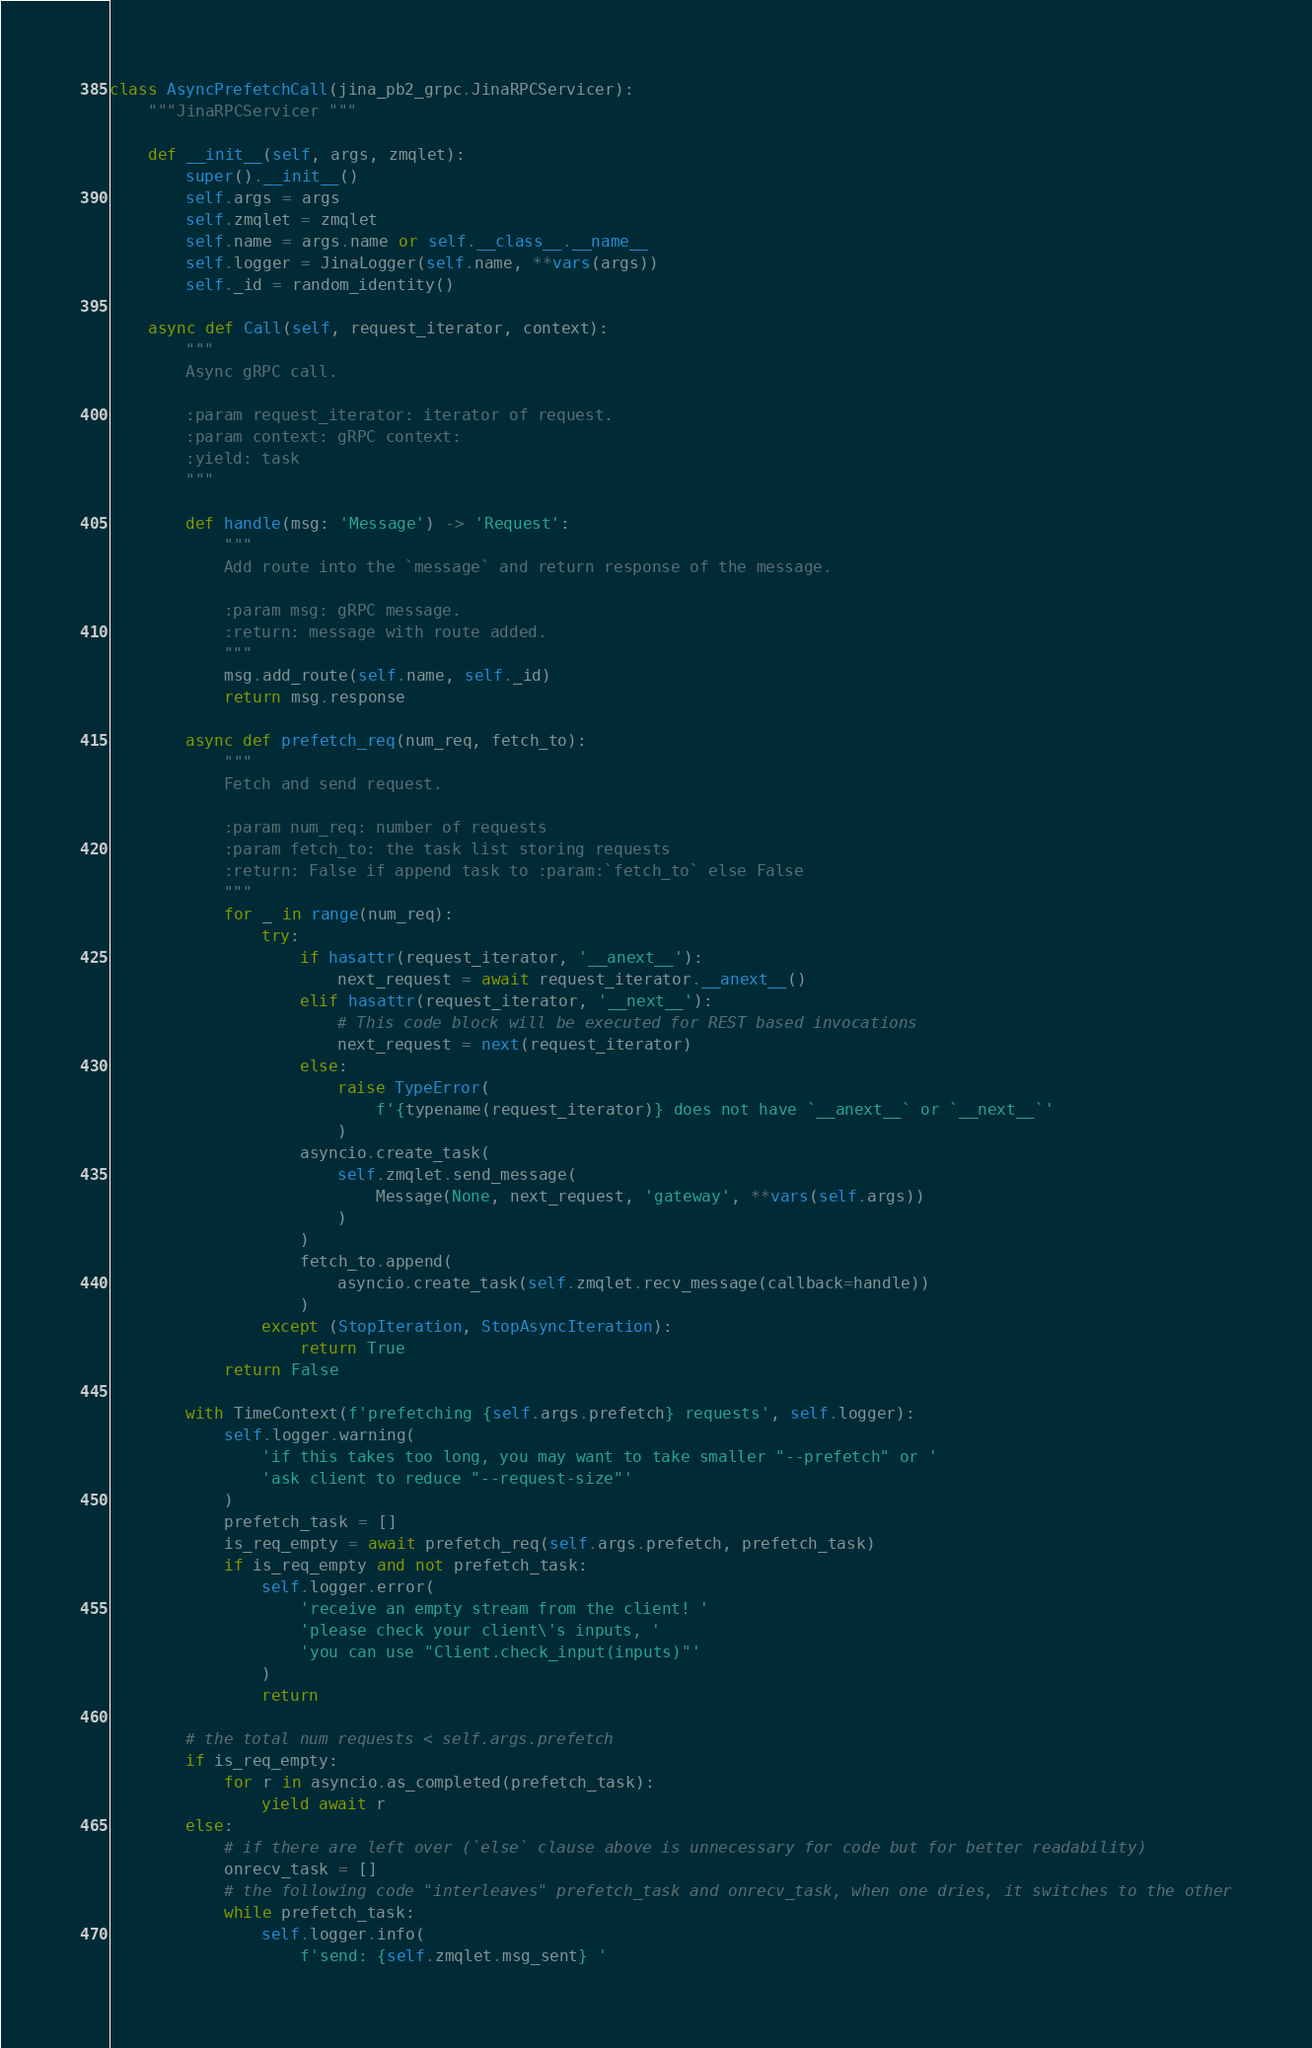<code> <loc_0><loc_0><loc_500><loc_500><_Python_>

class AsyncPrefetchCall(jina_pb2_grpc.JinaRPCServicer):
    """JinaRPCServicer """

    def __init__(self, args, zmqlet):
        super().__init__()
        self.args = args
        self.zmqlet = zmqlet
        self.name = args.name or self.__class__.__name__
        self.logger = JinaLogger(self.name, **vars(args))
        self._id = random_identity()

    async def Call(self, request_iterator, context):
        """
        Async gRPC call.

        :param request_iterator: iterator of request.
        :param context: gRPC context:
        :yield: task
        """

        def handle(msg: 'Message') -> 'Request':
            """
            Add route into the `message` and return response of the message.

            :param msg: gRPC message.
            :return: message with route added.
            """
            msg.add_route(self.name, self._id)
            return msg.response

        async def prefetch_req(num_req, fetch_to):
            """
            Fetch and send request.

            :param num_req: number of requests
            :param fetch_to: the task list storing requests
            :return: False if append task to :param:`fetch_to` else False
            """
            for _ in range(num_req):
                try:
                    if hasattr(request_iterator, '__anext__'):
                        next_request = await request_iterator.__anext__()
                    elif hasattr(request_iterator, '__next__'):
                        # This code block will be executed for REST based invocations
                        next_request = next(request_iterator)
                    else:
                        raise TypeError(
                            f'{typename(request_iterator)} does not have `__anext__` or `__next__`'
                        )
                    asyncio.create_task(
                        self.zmqlet.send_message(
                            Message(None, next_request, 'gateway', **vars(self.args))
                        )
                    )
                    fetch_to.append(
                        asyncio.create_task(self.zmqlet.recv_message(callback=handle))
                    )
                except (StopIteration, StopAsyncIteration):
                    return True
            return False

        with TimeContext(f'prefetching {self.args.prefetch} requests', self.logger):
            self.logger.warning(
                'if this takes too long, you may want to take smaller "--prefetch" or '
                'ask client to reduce "--request-size"'
            )
            prefetch_task = []
            is_req_empty = await prefetch_req(self.args.prefetch, prefetch_task)
            if is_req_empty and not prefetch_task:
                self.logger.error(
                    'receive an empty stream from the client! '
                    'please check your client\'s inputs, '
                    'you can use "Client.check_input(inputs)"'
                )
                return

        # the total num requests < self.args.prefetch
        if is_req_empty:
            for r in asyncio.as_completed(prefetch_task):
                yield await r
        else:
            # if there are left over (`else` clause above is unnecessary for code but for better readability)
            onrecv_task = []
            # the following code "interleaves" prefetch_task and onrecv_task, when one dries, it switches to the other
            while prefetch_task:
                self.logger.info(
                    f'send: {self.zmqlet.msg_sent} '</code> 